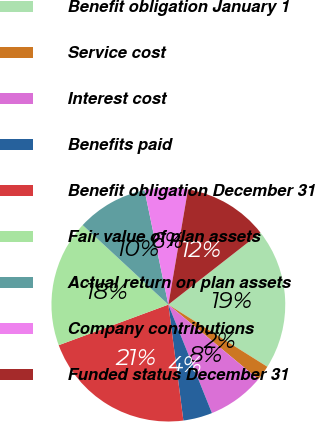<chart> <loc_0><loc_0><loc_500><loc_500><pie_chart><fcel>Benefit obligation January 1<fcel>Service cost<fcel>Interest cost<fcel>Benefits paid<fcel>Benefit obligation December 31<fcel>Fair value of plan assets<fcel>Actual return on plan assets<fcel>Company contributions<fcel>Funded status December 31<nl><fcel>19.47%<fcel>2.1%<fcel>7.89%<fcel>4.03%<fcel>21.4%<fcel>17.54%<fcel>9.82%<fcel>5.96%<fcel>11.75%<nl></chart> 